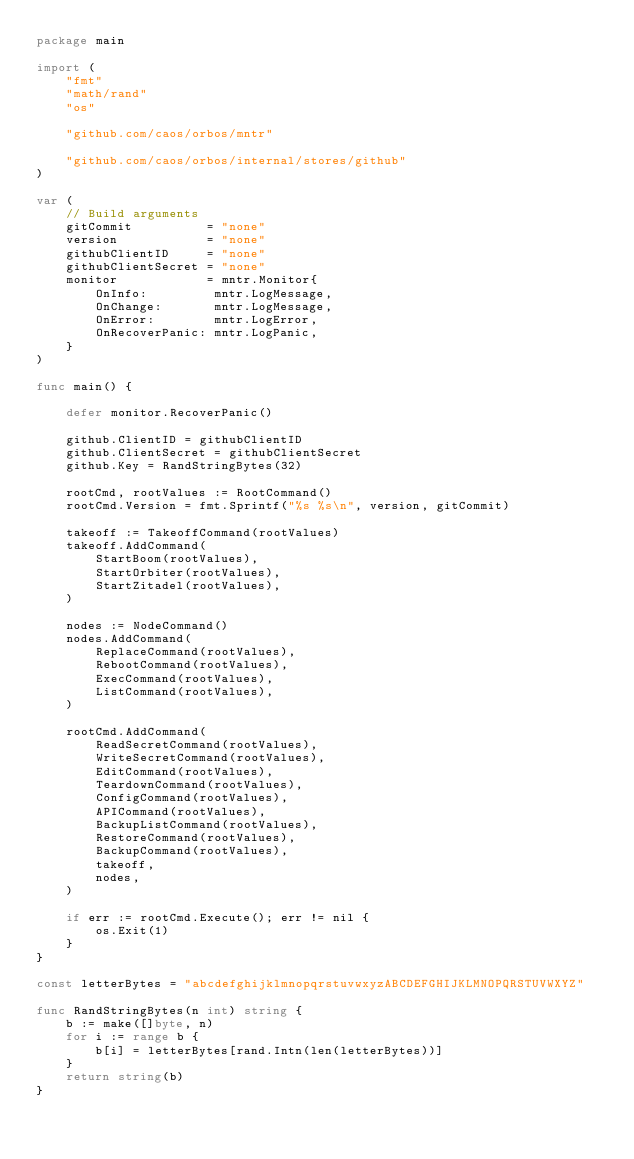Convert code to text. <code><loc_0><loc_0><loc_500><loc_500><_Go_>package main

import (
	"fmt"
	"math/rand"
	"os"

	"github.com/caos/orbos/mntr"

	"github.com/caos/orbos/internal/stores/github"
)

var (
	// Build arguments
	gitCommit          = "none"
	version            = "none"
	githubClientID     = "none"
	githubClientSecret = "none"
	monitor            = mntr.Monitor{
		OnInfo:         mntr.LogMessage,
		OnChange:       mntr.LogMessage,
		OnError:        mntr.LogError,
		OnRecoverPanic: mntr.LogPanic,
	}
)

func main() {

	defer monitor.RecoverPanic()

	github.ClientID = githubClientID
	github.ClientSecret = githubClientSecret
	github.Key = RandStringBytes(32)

	rootCmd, rootValues := RootCommand()
	rootCmd.Version = fmt.Sprintf("%s %s\n", version, gitCommit)

	takeoff := TakeoffCommand(rootValues)
	takeoff.AddCommand(
		StartBoom(rootValues),
		StartOrbiter(rootValues),
		StartZitadel(rootValues),
	)

	nodes := NodeCommand()
	nodes.AddCommand(
		ReplaceCommand(rootValues),
		RebootCommand(rootValues),
		ExecCommand(rootValues),
		ListCommand(rootValues),
	)

	rootCmd.AddCommand(
		ReadSecretCommand(rootValues),
		WriteSecretCommand(rootValues),
		EditCommand(rootValues),
		TeardownCommand(rootValues),
		ConfigCommand(rootValues),
		APICommand(rootValues),
		BackupListCommand(rootValues),
		RestoreCommand(rootValues),
		BackupCommand(rootValues),
		takeoff,
		nodes,
	)

	if err := rootCmd.Execute(); err != nil {
		os.Exit(1)
	}
}

const letterBytes = "abcdefghijklmnopqrstuvwxyzABCDEFGHIJKLMNOPQRSTUVWXYZ"

func RandStringBytes(n int) string {
	b := make([]byte, n)
	for i := range b {
		b[i] = letterBytes[rand.Intn(len(letterBytes))]
	}
	return string(b)
}
</code> 